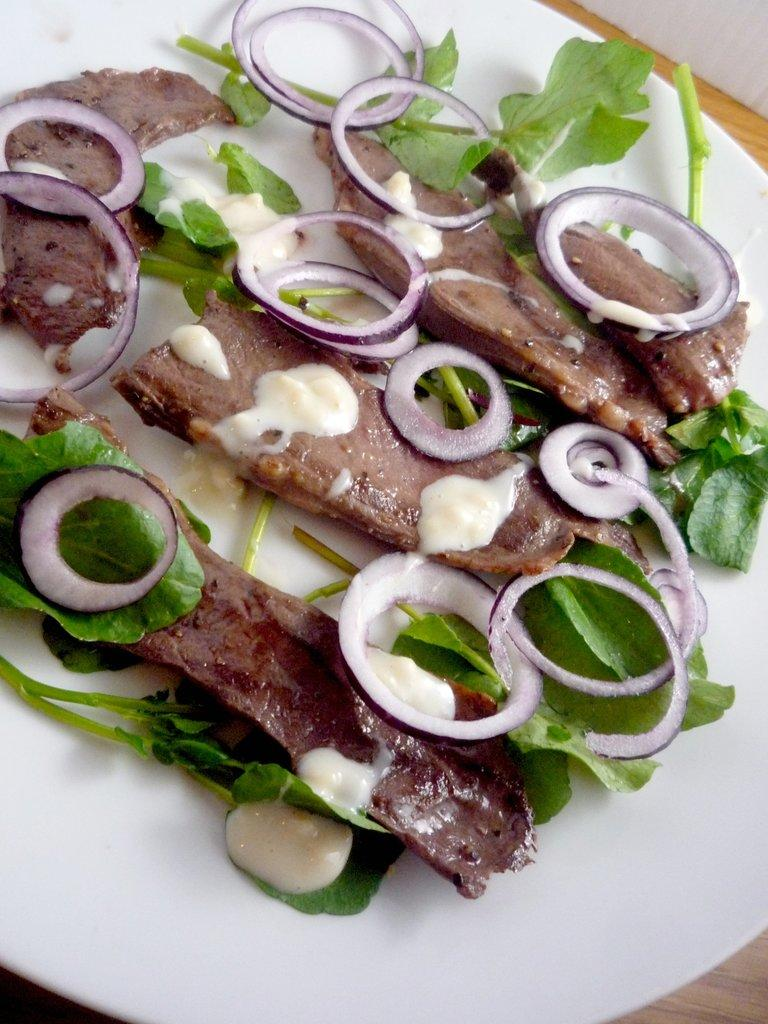What is on the plate that is visible in the image? There is food on a plate in the image. Where is the plate located in the image? The plate is placed on a table. What type of coast can be seen in the image? There is no coast visible in the image; it only features a plate of food on a table. What flavor of the bottle is depicted in the image? There is no bottle present in the image, so it is not possible to determine its flavor. 